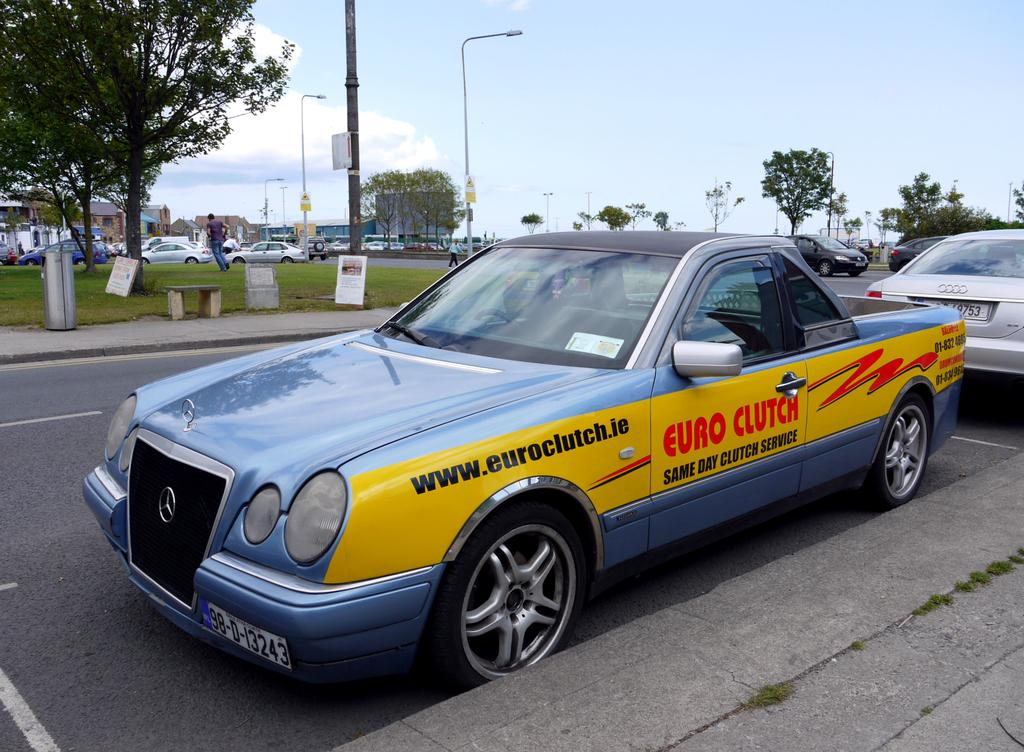<image>
Present a compact description of the photo's key features. A parked car has advertisement for Euro Clutch One day service 